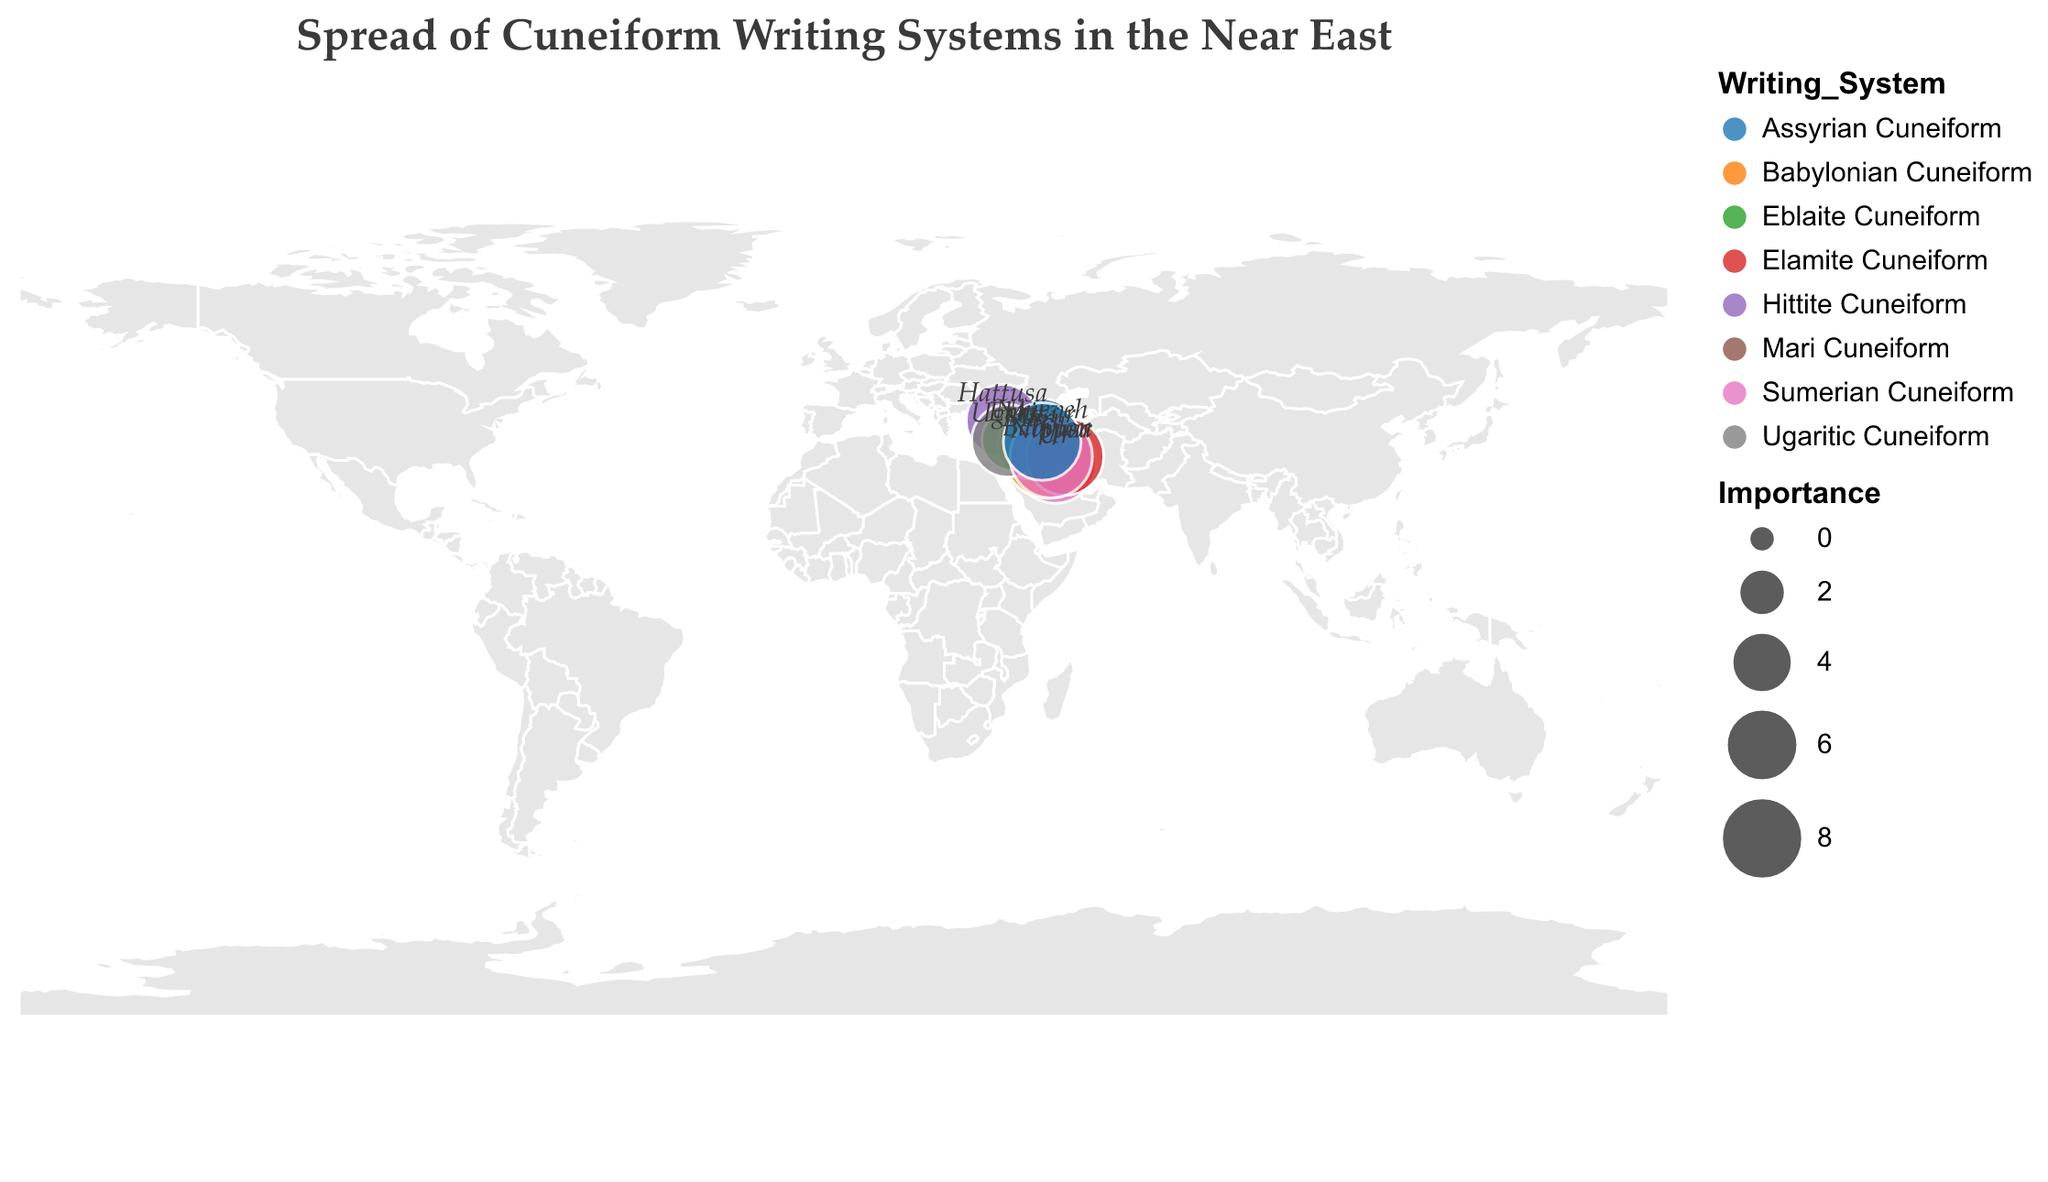Which location has the earliest recorded use of a cuneiform writing system according to the figure? The figure shows dots with labels and years. The earliest year indicated is -2800 at Ur.
Answer: Ur Which writing system is shown to be most important in Babylon, judging by the size of the circle? The size of the circle indicates importance. The figure shows Babylon with the largest circle and Babylonian Cuneiform.
Answer: Babylonian Cuneiform How many different locations are represented in the figure? Count the number of unique labels given to the different circles on the map. There are labels for Ur, Babylon, Nineveh, Hattusa, Mari, Ebla, Ugarit, Susa, Nippur, and Assur.
Answer: 10 Which two locations have the same importance value of 7? Look for circles of the same size with importance 7 and check their labels. The locations are Nineveh, Susa, and Assur, all with an importance of 7.
Answer: Nineveh, Susa, Assur What is the average importance of the cuneiform writing systems at Mari, Ebla, and Ugarit? Look up the importance values for Mari (5), Ebla (4), and Ugarit (6). The average is calculated as (5 + 4 + 6) / 3.
Answer: 5 Which location adopted the Elamite Cuneiform, and what year did it happen? Elamite Cuneiform is used at Susa, and the year is indicated as -2200.
Answer: Susa, -2200 What is the color used to represent Sumerian Cuneiform in the figure? Look at the legend for the color associated with Sumerian Cuneiform. It is displayed using a unique categorical color.
Answer: Specific color assigned in the figure (varies by visual representation) How many writing systems started to spread before -2000 BCE? Identify dots on the map with years earlier than -2000 BCE. There are six: Ur, Nippur, Susa, Mari, Ebla, and Hattusa.
Answer: 6 Which two locations appear closest geographically to each other? Examine the positions of the circles on the map and determine the proximity. Assur and Nineveh appear closest to each other.
Answer: Assur, Nineveh 